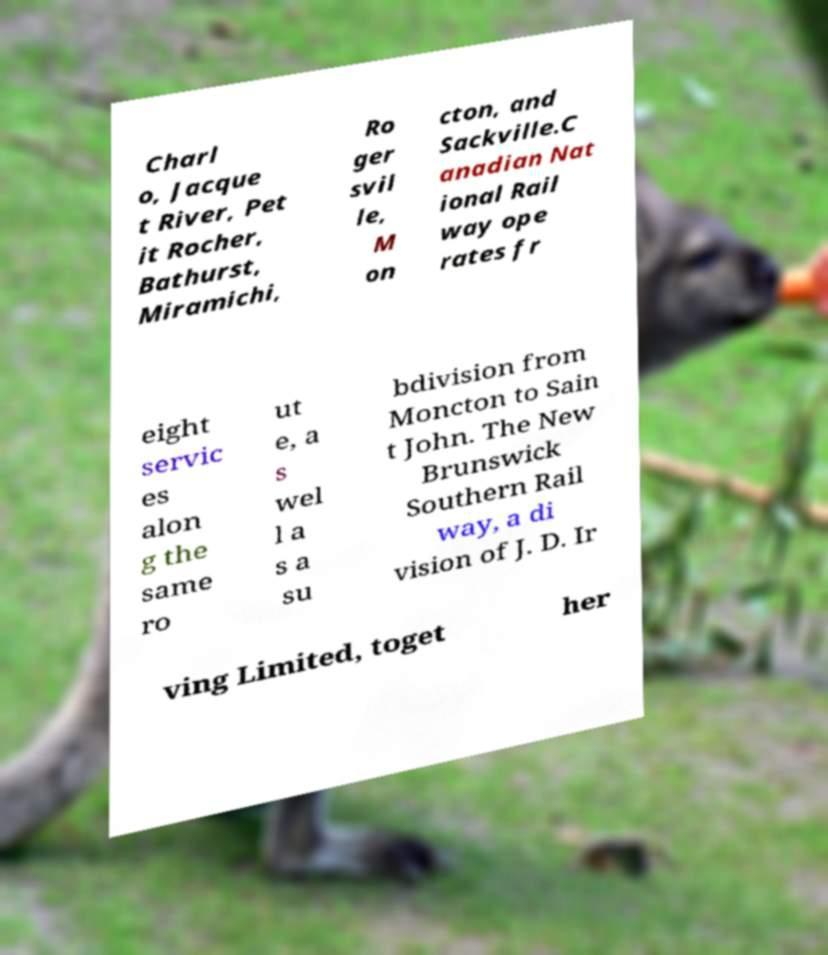What messages or text are displayed in this image? I need them in a readable, typed format. Charl o, Jacque t River, Pet it Rocher, Bathurst, Miramichi, Ro ger svil le, M on cton, and Sackville.C anadian Nat ional Rail way ope rates fr eight servic es alon g the same ro ut e, a s wel l a s a su bdivision from Moncton to Sain t John. The New Brunswick Southern Rail way, a di vision of J. D. Ir ving Limited, toget her 